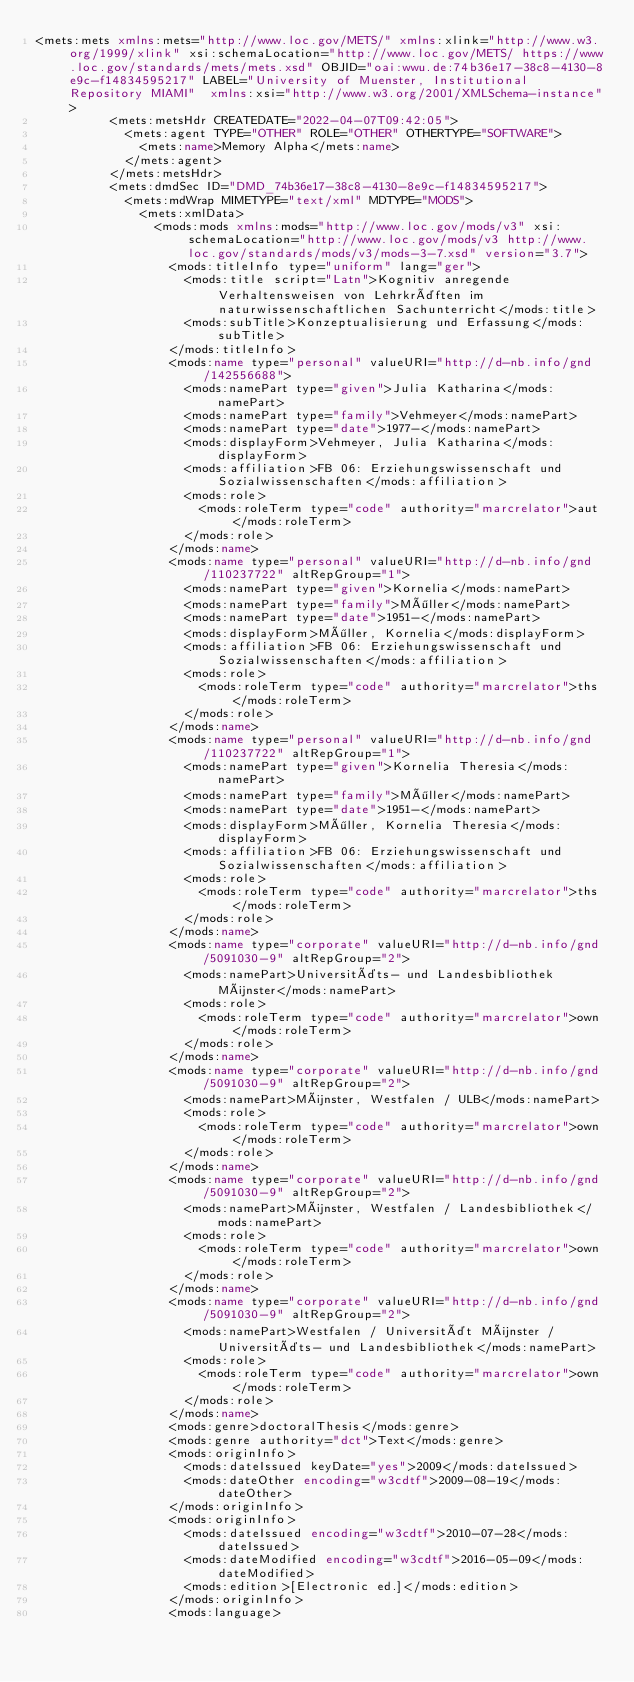Convert code to text. <code><loc_0><loc_0><loc_500><loc_500><_XML_><mets:mets xmlns:mets="http://www.loc.gov/METS/" xmlns:xlink="http://www.w3.org/1999/xlink" xsi:schemaLocation="http://www.loc.gov/METS/ https://www.loc.gov/standards/mets/mets.xsd" OBJID="oai:wwu.de:74b36e17-38c8-4130-8e9c-f14834595217" LABEL="University of Muenster, Institutional Repository MIAMI"  xmlns:xsi="http://www.w3.org/2001/XMLSchema-instance">
          <mets:metsHdr CREATEDATE="2022-04-07T09:42:05">
            <mets:agent TYPE="OTHER" ROLE="OTHER" OTHERTYPE="SOFTWARE">
              <mets:name>Memory Alpha</mets:name>
            </mets:agent>
          </mets:metsHdr>
          <mets:dmdSec ID="DMD_74b36e17-38c8-4130-8e9c-f14834595217">
            <mets:mdWrap MIMETYPE="text/xml" MDTYPE="MODS">
              <mets:xmlData>
                <mods:mods xmlns:mods="http://www.loc.gov/mods/v3" xsi:schemaLocation="http://www.loc.gov/mods/v3 http://www.loc.gov/standards/mods/v3/mods-3-7.xsd" version="3.7">
                  <mods:titleInfo type="uniform" lang="ger">
                    <mods:title script="Latn">Kognitiv anregende Verhaltensweisen von Lehrkräften im naturwissenschaftlichen Sachunterricht</mods:title>
                    <mods:subTitle>Konzeptualisierung und Erfassung</mods:subTitle>
                  </mods:titleInfo>
                  <mods:name type="personal" valueURI="http://d-nb.info/gnd/142556688">
                    <mods:namePart type="given">Julia Katharina</mods:namePart>
                    <mods:namePart type="family">Vehmeyer</mods:namePart>
                    <mods:namePart type="date">1977-</mods:namePart>
                    <mods:displayForm>Vehmeyer, Julia Katharina</mods:displayForm>
                    <mods:affiliation>FB 06: Erziehungswissenschaft und Sozialwissenschaften</mods:affiliation>
                    <mods:role>
                      <mods:roleTerm type="code" authority="marcrelator">aut</mods:roleTerm>
                    </mods:role>
                  </mods:name>
                  <mods:name type="personal" valueURI="http://d-nb.info/gnd/110237722" altRepGroup="1">
                    <mods:namePart type="given">Kornelia</mods:namePart>
                    <mods:namePart type="family">Möller</mods:namePart>
                    <mods:namePart type="date">1951-</mods:namePart>
                    <mods:displayForm>Möller, Kornelia</mods:displayForm>
                    <mods:affiliation>FB 06: Erziehungswissenschaft und Sozialwissenschaften</mods:affiliation>
                    <mods:role>
                      <mods:roleTerm type="code" authority="marcrelator">ths</mods:roleTerm>
                    </mods:role>
                  </mods:name>
                  <mods:name type="personal" valueURI="http://d-nb.info/gnd/110237722" altRepGroup="1">
                    <mods:namePart type="given">Kornelia Theresia</mods:namePart>
                    <mods:namePart type="family">Möller</mods:namePart>
                    <mods:namePart type="date">1951-</mods:namePart>
                    <mods:displayForm>Möller, Kornelia Theresia</mods:displayForm>
                    <mods:affiliation>FB 06: Erziehungswissenschaft und Sozialwissenschaften</mods:affiliation>
                    <mods:role>
                      <mods:roleTerm type="code" authority="marcrelator">ths</mods:roleTerm>
                    </mods:role>
                  </mods:name>
                  <mods:name type="corporate" valueURI="http://d-nb.info/gnd/5091030-9" altRepGroup="2">
                    <mods:namePart>Universitäts- und Landesbibliothek Münster</mods:namePart>
                    <mods:role>
                      <mods:roleTerm type="code" authority="marcrelator">own</mods:roleTerm>
                    </mods:role>
                  </mods:name>
                  <mods:name type="corporate" valueURI="http://d-nb.info/gnd/5091030-9" altRepGroup="2">
                    <mods:namePart>Münster, Westfalen / ULB</mods:namePart>
                    <mods:role>
                      <mods:roleTerm type="code" authority="marcrelator">own</mods:roleTerm>
                    </mods:role>
                  </mods:name>
                  <mods:name type="corporate" valueURI="http://d-nb.info/gnd/5091030-9" altRepGroup="2">
                    <mods:namePart>Münster, Westfalen / Landesbibliothek</mods:namePart>
                    <mods:role>
                      <mods:roleTerm type="code" authority="marcrelator">own</mods:roleTerm>
                    </mods:role>
                  </mods:name>
                  <mods:name type="corporate" valueURI="http://d-nb.info/gnd/5091030-9" altRepGroup="2">
                    <mods:namePart>Westfalen / Universität Münster / Universitäts- und Landesbibliothek</mods:namePart>
                    <mods:role>
                      <mods:roleTerm type="code" authority="marcrelator">own</mods:roleTerm>
                    </mods:role>
                  </mods:name>
                  <mods:genre>doctoralThesis</mods:genre>
                  <mods:genre authority="dct">Text</mods:genre>
                  <mods:originInfo>
                    <mods:dateIssued keyDate="yes">2009</mods:dateIssued>
                    <mods:dateOther encoding="w3cdtf">2009-08-19</mods:dateOther>
                  </mods:originInfo>
                  <mods:originInfo>
                    <mods:dateIssued encoding="w3cdtf">2010-07-28</mods:dateIssued>
                    <mods:dateModified encoding="w3cdtf">2016-05-09</mods:dateModified>
                    <mods:edition>[Electronic ed.]</mods:edition>
                  </mods:originInfo>
                  <mods:language></code> 